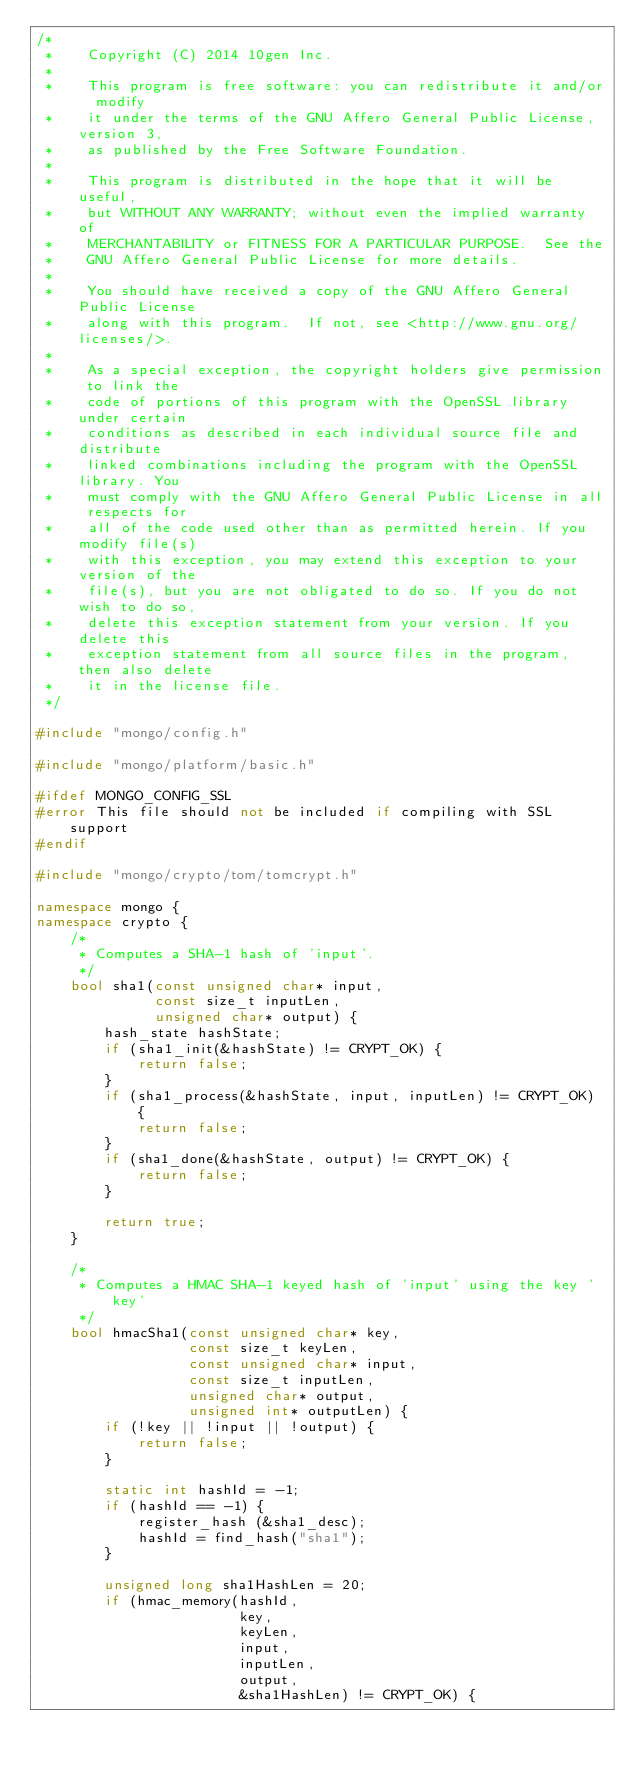Convert code to text. <code><loc_0><loc_0><loc_500><loc_500><_C++_>/*
 *    Copyright (C) 2014 10gen Inc.
 *
 *    This program is free software: you can redistribute it and/or  modify
 *    it under the terms of the GNU Affero General Public License, version 3,
 *    as published by the Free Software Foundation.
 *
 *    This program is distributed in the hope that it will be useful,
 *    but WITHOUT ANY WARRANTY; without even the implied warranty of
 *    MERCHANTABILITY or FITNESS FOR A PARTICULAR PURPOSE.  See the
 *    GNU Affero General Public License for more details.
 *
 *    You should have received a copy of the GNU Affero General Public License
 *    along with this program.  If not, see <http://www.gnu.org/licenses/>.
 *
 *    As a special exception, the copyright holders give permission to link the
 *    code of portions of this program with the OpenSSL library under certain
 *    conditions as described in each individual source file and distribute
 *    linked combinations including the program with the OpenSSL library. You
 *    must comply with the GNU Affero General Public License in all respects for
 *    all of the code used other than as permitted herein. If you modify file(s)
 *    with this exception, you may extend this exception to your version of the
 *    file(s), but you are not obligated to do so. If you do not wish to do so,
 *    delete this exception statement from your version. If you delete this
 *    exception statement from all source files in the program, then also delete
 *    it in the license file.
 */

#include "mongo/config.h"

#include "mongo/platform/basic.h"

#ifdef MONGO_CONFIG_SSL
#error This file should not be included if compiling with SSL support
#endif

#include "mongo/crypto/tom/tomcrypt.h"

namespace mongo {
namespace crypto {
    /*
     * Computes a SHA-1 hash of 'input'.
     */
    bool sha1(const unsigned char* input,
              const size_t inputLen,
              unsigned char* output) {
        hash_state hashState;
        if (sha1_init(&hashState) != CRYPT_OK) {
            return false;
        }
        if (sha1_process(&hashState, input, inputLen) != CRYPT_OK) {
            return false;
        }
        if (sha1_done(&hashState, output) != CRYPT_OK) {
            return false;
        }

        return true;
    }

    /*
     * Computes a HMAC SHA-1 keyed hash of 'input' using the key 'key'
     */
    bool hmacSha1(const unsigned char* key,
                  const size_t keyLen,
                  const unsigned char* input,
                  const size_t inputLen,
                  unsigned char* output,
                  unsigned int* outputLen) {
        if (!key || !input || !output) {
            return false;
        }

        static int hashId = -1;
        if (hashId == -1) {
            register_hash (&sha1_desc);
            hashId = find_hash("sha1");
        }

        unsigned long sha1HashLen = 20;
        if (hmac_memory(hashId,
                        key,
                        keyLen,
                        input,
                        inputLen,
                        output,
                        &sha1HashLen) != CRYPT_OK) {</code> 